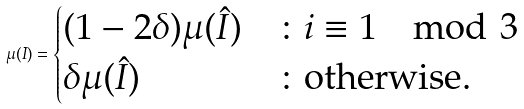<formula> <loc_0><loc_0><loc_500><loc_500>\mu ( I ) = \begin{cases} ( 1 - 2 \delta ) \mu ( \hat { I } ) & \colon i \equiv 1 \mod 3 \\ \delta \mu ( \hat { I } ) & \colon \text {otherwise.} \end{cases}</formula> 